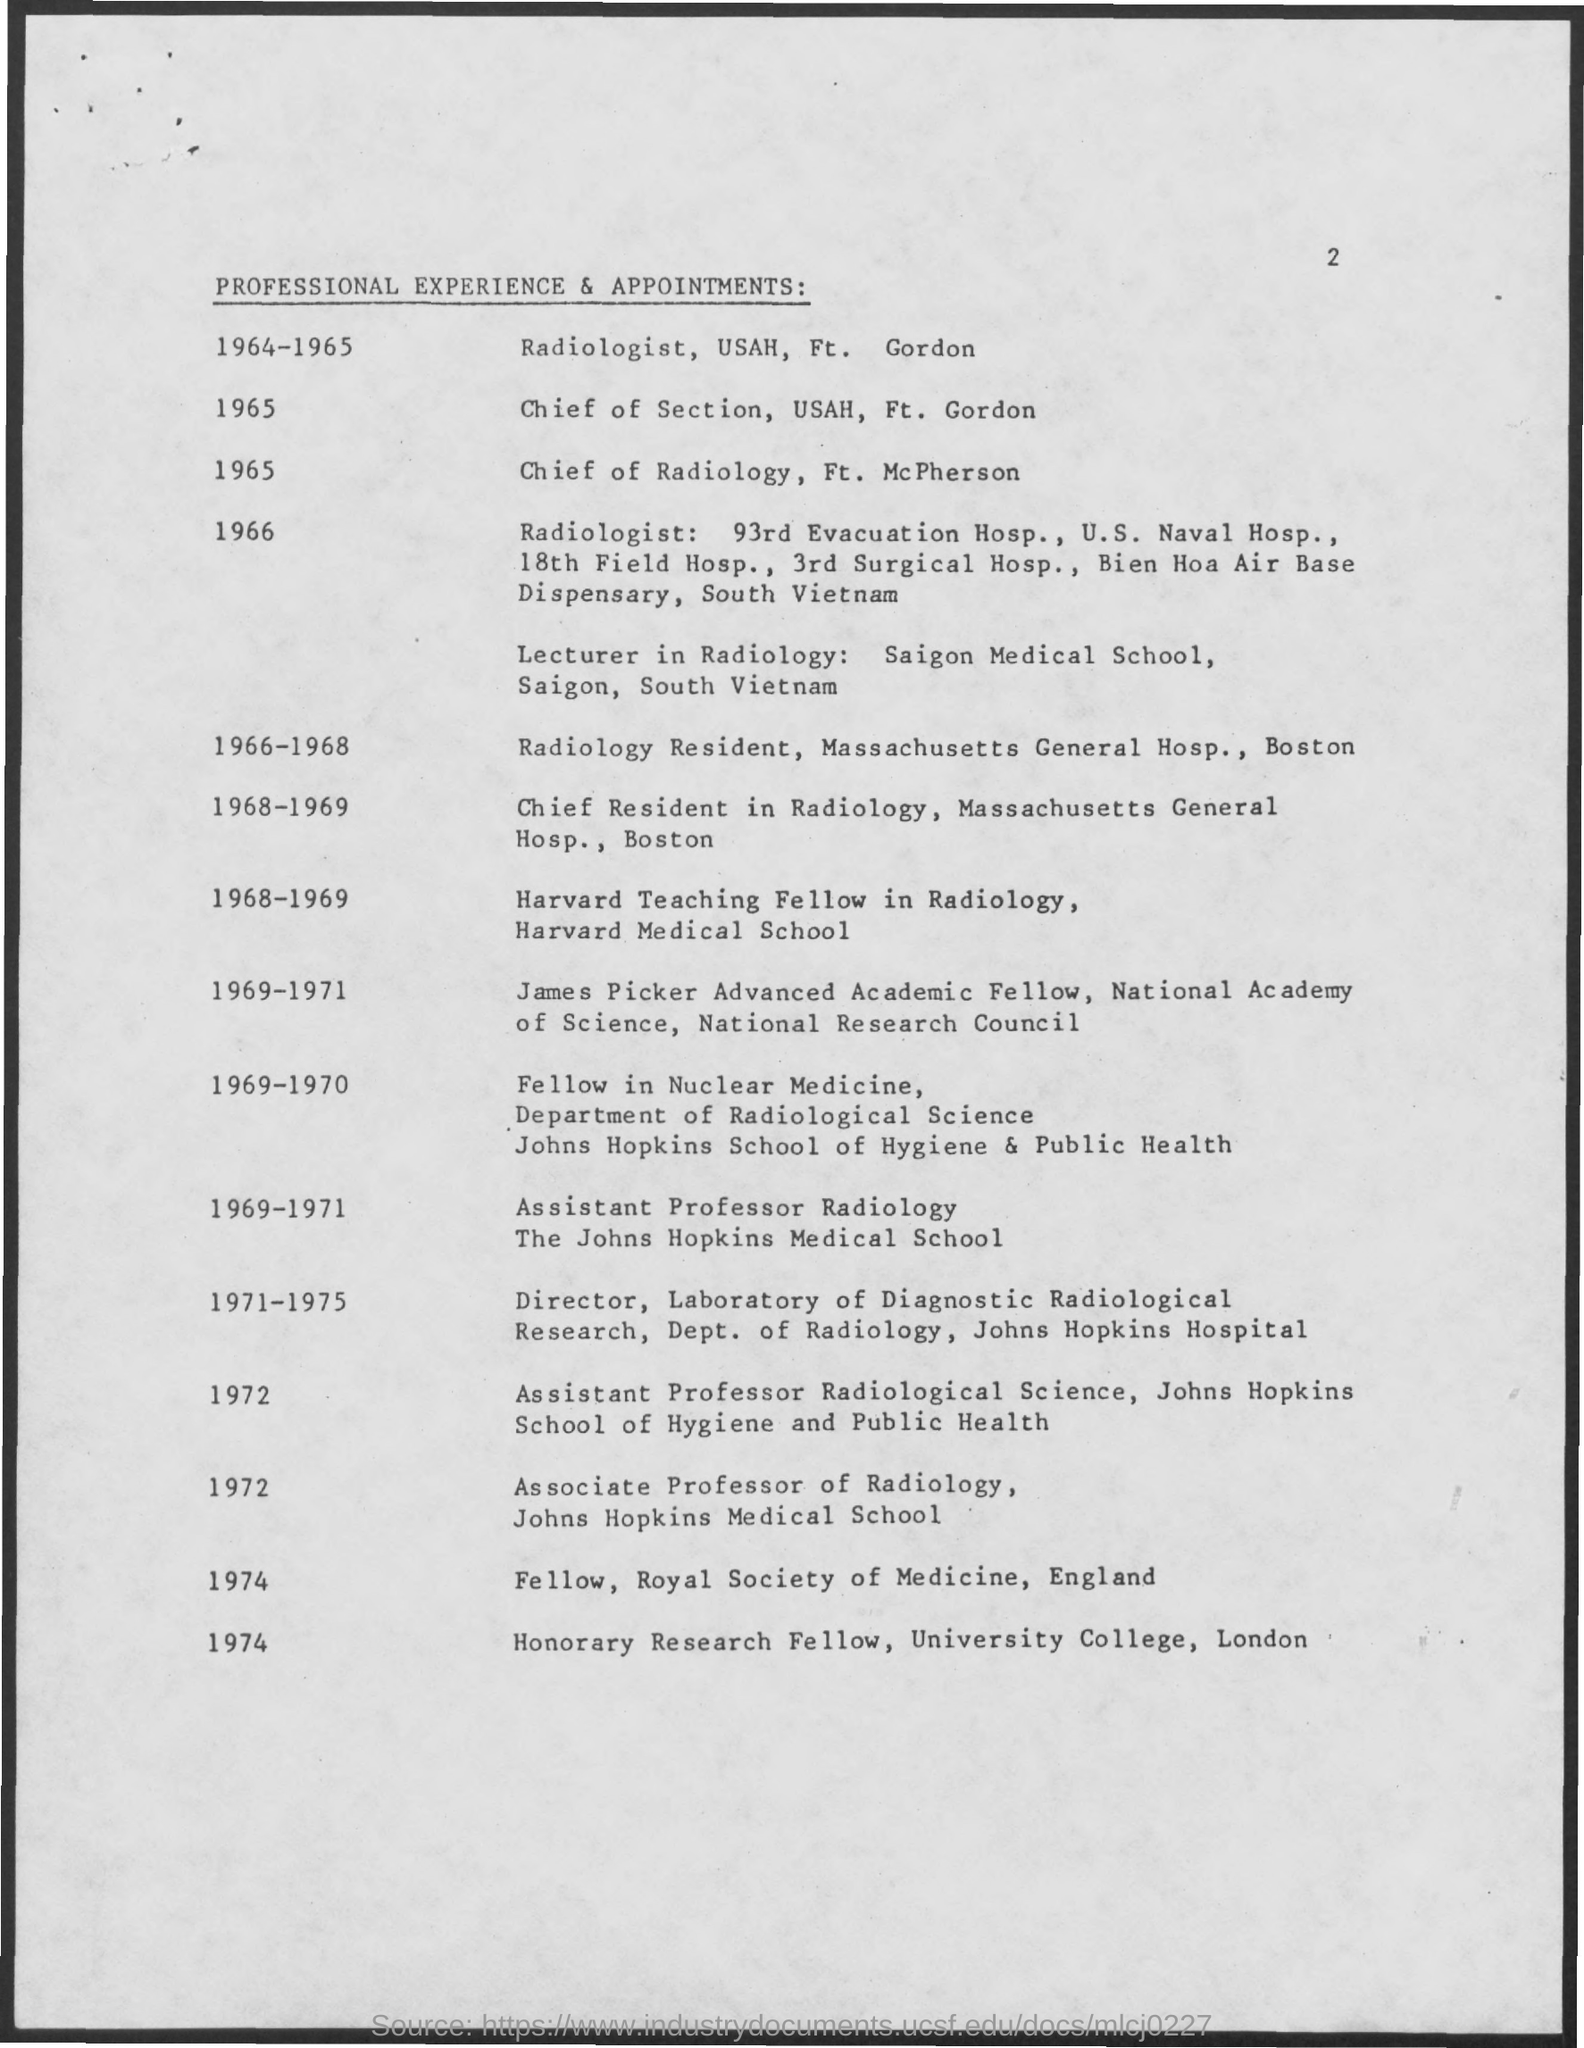Identify some key points in this picture. The page number is 2, as declared. The title of the document is 'Professional Experience & Appointments:...' In 1965, FT. MCPHERSON was the chief of radiology. In 1965, USAH was the Chief of Section at F.T. Gordon. 